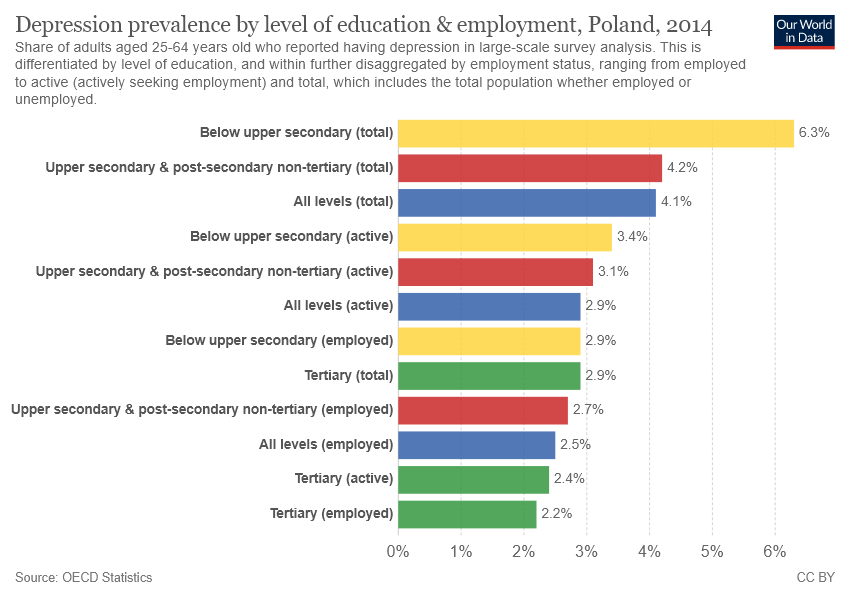Draw attention to some important aspects in this diagram. The sum of all the yellow bars is 12.6. The bar graph depicts multiple levels of depression prevalence by education, ranging from 12% to 30%. 